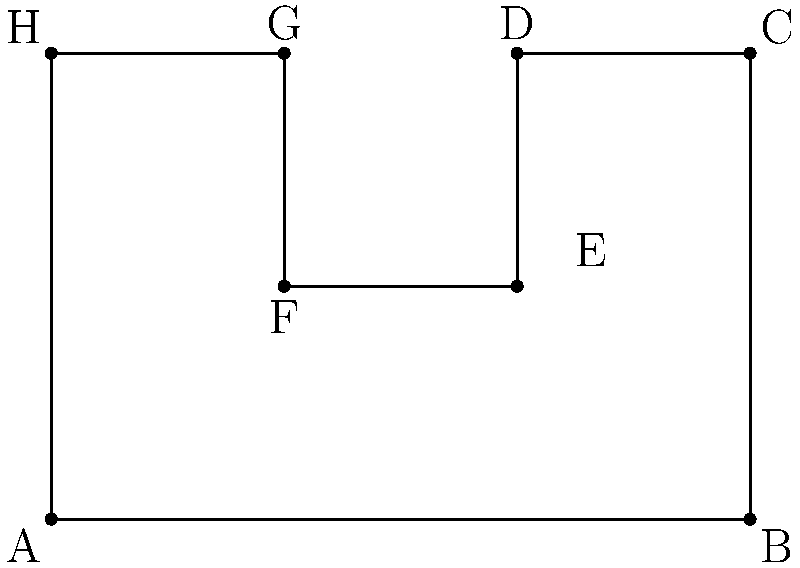As an interior designer, you're working on a project with an irregularly shaped room as shown in the diagram. Using vector representation, calculate the total area of this room in square meters. To calculate the area of this irregularly shaped room using vector representation, we can follow these steps:

1. Divide the room into rectangles:
   - Rectangle ABCH (6m x 4m)
   - Rectangle DEFG (2m x 2m)

2. Calculate the area of each rectangle:
   - Area of ABCH: $A_1 = 6 \times 4 = 24$ m²
   - Area of DEFG: $A_2 = 2 \times 2 = 4$ m²

3. Use vector representation to calculate the areas:
   For rectangle ABCH:
   $\vec{AB} = (6,0)$
   $\vec{AH} = (0,4)$
   Area = $|\vec{AB} \times \vec{AH}| = |(6,0) \times (0,4)| = |24| = 24$ m²

   For rectangle DEFG:
   $\vec{DE} = (0,-2)$
   $\vec{DG} = (-2,0)$
   Area = $|\vec{DE} \times \vec{DG}| = |(0,-2) \times (-2,0)| = |4| = 4$ m²

4. Sum the areas:
   Total Area = $A_1 + A_2 = 24 + 4 = 28$ m²

Therefore, the total area of the irregularly shaped room is 28 square meters.
Answer: 28 m² 